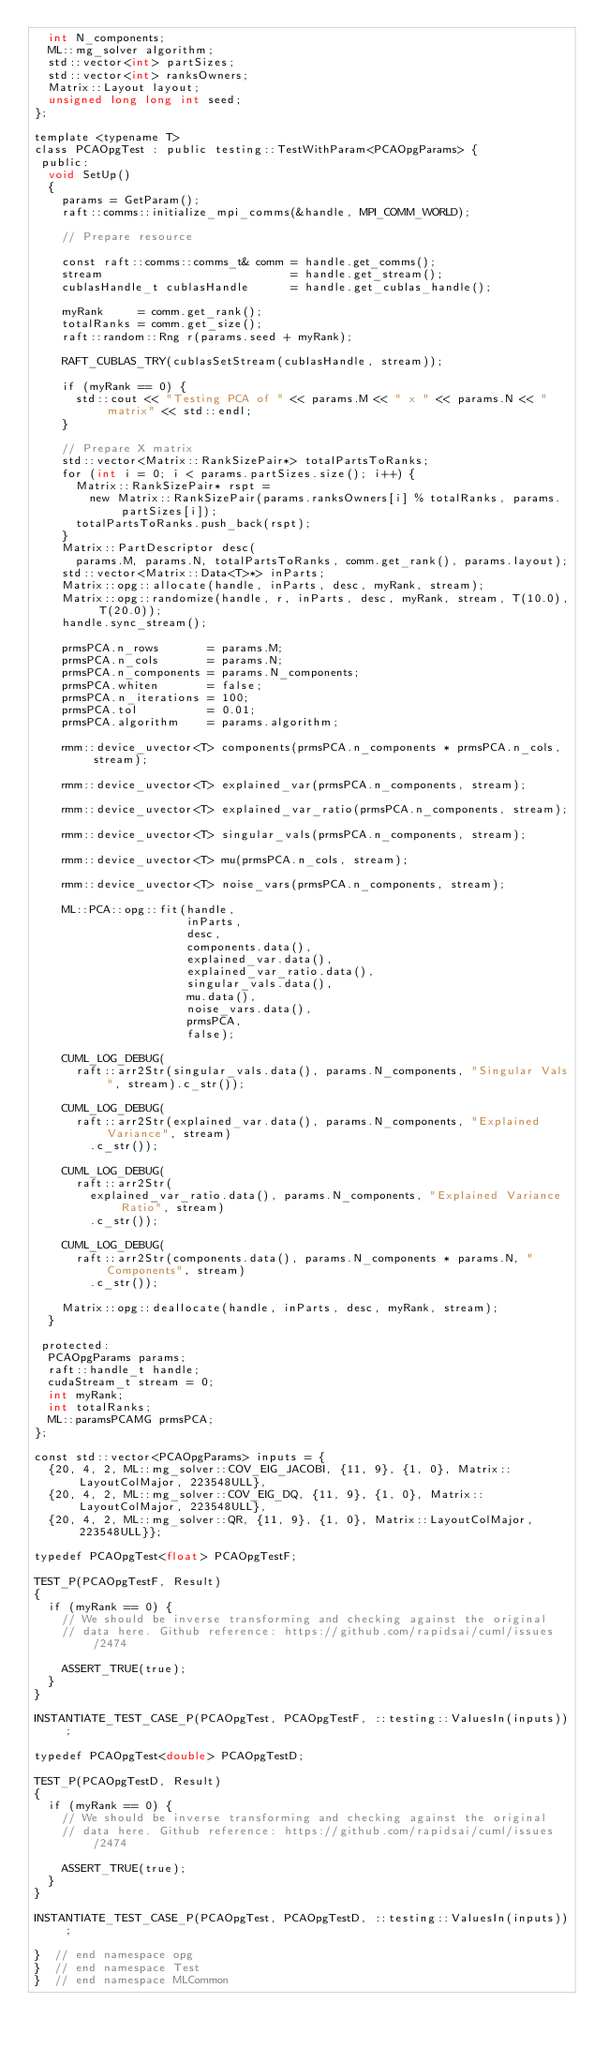<code> <loc_0><loc_0><loc_500><loc_500><_Cuda_>  int N_components;
  ML::mg_solver algorithm;
  std::vector<int> partSizes;
  std::vector<int> ranksOwners;
  Matrix::Layout layout;
  unsigned long long int seed;
};

template <typename T>
class PCAOpgTest : public testing::TestWithParam<PCAOpgParams> {
 public:
  void SetUp()
  {
    params = GetParam();
    raft::comms::initialize_mpi_comms(&handle, MPI_COMM_WORLD);

    // Prepare resource

    const raft::comms::comms_t& comm = handle.get_comms();
    stream                           = handle.get_stream();
    cublasHandle_t cublasHandle      = handle.get_cublas_handle();

    myRank     = comm.get_rank();
    totalRanks = comm.get_size();
    raft::random::Rng r(params.seed + myRank);

    RAFT_CUBLAS_TRY(cublasSetStream(cublasHandle, stream));

    if (myRank == 0) {
      std::cout << "Testing PCA of " << params.M << " x " << params.N << " matrix" << std::endl;
    }

    // Prepare X matrix
    std::vector<Matrix::RankSizePair*> totalPartsToRanks;
    for (int i = 0; i < params.partSizes.size(); i++) {
      Matrix::RankSizePair* rspt =
        new Matrix::RankSizePair(params.ranksOwners[i] % totalRanks, params.partSizes[i]);
      totalPartsToRanks.push_back(rspt);
    }
    Matrix::PartDescriptor desc(
      params.M, params.N, totalPartsToRanks, comm.get_rank(), params.layout);
    std::vector<Matrix::Data<T>*> inParts;
    Matrix::opg::allocate(handle, inParts, desc, myRank, stream);
    Matrix::opg::randomize(handle, r, inParts, desc, myRank, stream, T(10.0), T(20.0));
    handle.sync_stream();

    prmsPCA.n_rows       = params.M;
    prmsPCA.n_cols       = params.N;
    prmsPCA.n_components = params.N_components;
    prmsPCA.whiten       = false;
    prmsPCA.n_iterations = 100;
    prmsPCA.tol          = 0.01;
    prmsPCA.algorithm    = params.algorithm;

    rmm::device_uvector<T> components(prmsPCA.n_components * prmsPCA.n_cols, stream);

    rmm::device_uvector<T> explained_var(prmsPCA.n_components, stream);

    rmm::device_uvector<T> explained_var_ratio(prmsPCA.n_components, stream);

    rmm::device_uvector<T> singular_vals(prmsPCA.n_components, stream);

    rmm::device_uvector<T> mu(prmsPCA.n_cols, stream);

    rmm::device_uvector<T> noise_vars(prmsPCA.n_components, stream);

    ML::PCA::opg::fit(handle,
                      inParts,
                      desc,
                      components.data(),
                      explained_var.data(),
                      explained_var_ratio.data(),
                      singular_vals.data(),
                      mu.data(),
                      noise_vars.data(),
                      prmsPCA,
                      false);

    CUML_LOG_DEBUG(
      raft::arr2Str(singular_vals.data(), params.N_components, "Singular Vals", stream).c_str());

    CUML_LOG_DEBUG(
      raft::arr2Str(explained_var.data(), params.N_components, "Explained Variance", stream)
        .c_str());

    CUML_LOG_DEBUG(
      raft::arr2Str(
        explained_var_ratio.data(), params.N_components, "Explained Variance Ratio", stream)
        .c_str());

    CUML_LOG_DEBUG(
      raft::arr2Str(components.data(), params.N_components * params.N, "Components", stream)
        .c_str());

    Matrix::opg::deallocate(handle, inParts, desc, myRank, stream);
  }

 protected:
  PCAOpgParams params;
  raft::handle_t handle;
  cudaStream_t stream = 0;
  int myRank;
  int totalRanks;
  ML::paramsPCAMG prmsPCA;
};

const std::vector<PCAOpgParams> inputs = {
  {20, 4, 2, ML::mg_solver::COV_EIG_JACOBI, {11, 9}, {1, 0}, Matrix::LayoutColMajor, 223548ULL},
  {20, 4, 2, ML::mg_solver::COV_EIG_DQ, {11, 9}, {1, 0}, Matrix::LayoutColMajor, 223548ULL},
  {20, 4, 2, ML::mg_solver::QR, {11, 9}, {1, 0}, Matrix::LayoutColMajor, 223548ULL}};

typedef PCAOpgTest<float> PCAOpgTestF;

TEST_P(PCAOpgTestF, Result)
{
  if (myRank == 0) {
    // We should be inverse transforming and checking against the original
    // data here. Github reference: https://github.com/rapidsai/cuml/issues/2474

    ASSERT_TRUE(true);
  }
}

INSTANTIATE_TEST_CASE_P(PCAOpgTest, PCAOpgTestF, ::testing::ValuesIn(inputs));

typedef PCAOpgTest<double> PCAOpgTestD;

TEST_P(PCAOpgTestD, Result)
{
  if (myRank == 0) {
    // We should be inverse transforming and checking against the original
    // data here. Github reference: https://github.com/rapidsai/cuml/issues/2474

    ASSERT_TRUE(true);
  }
}

INSTANTIATE_TEST_CASE_P(PCAOpgTest, PCAOpgTestD, ::testing::ValuesIn(inputs));

}  // end namespace opg
}  // end namespace Test
}  // end namespace MLCommon
</code> 